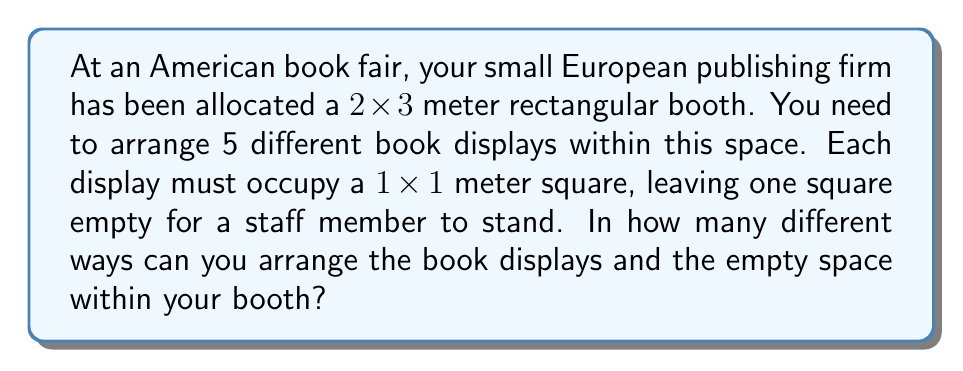Can you answer this question? Let's approach this step-by-step:

1) First, we need to understand what we're counting. We have a 2x3 grid (6 squares total) and we need to choose 5 squares for book displays, leaving 1 square empty.

2) This is equivalent to choosing 1 square to be empty out of 6 total squares. Once we choose the empty square, the book displays will occupy all other squares.

3) The number of ways to choose 1 square out of 6 is given by the combination formula:

   $$\binom{6}{1} = \frac{6!}{1!(6-1)!} = \frac{6!}{1!5!}$$

4) Calculating this:
   $$\frac{6 \cdot 5!}{1 \cdot 5!} = 6$$

5) Therefore, there are 6 different ways to arrange the empty space (and consequently, the book displays) within the booth.

6) Note: This solution assumes that the book displays are indistinguishable. If the 5 book displays were distinct, we would need to multiply this result by 5! to account for the different permutations of the displays.
Answer: 6 